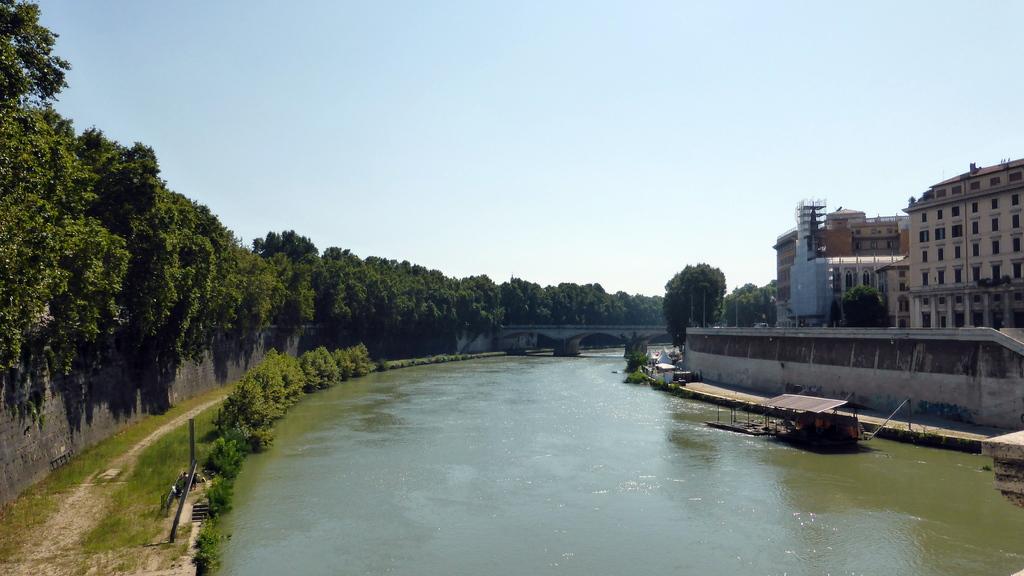How would you summarize this image in a sentence or two? In this image there is a lake, on either side of the lake there are trees and a path, on the right side there are buildings and trees, on the left side there is a wall and trees, in the background there is the sky. 